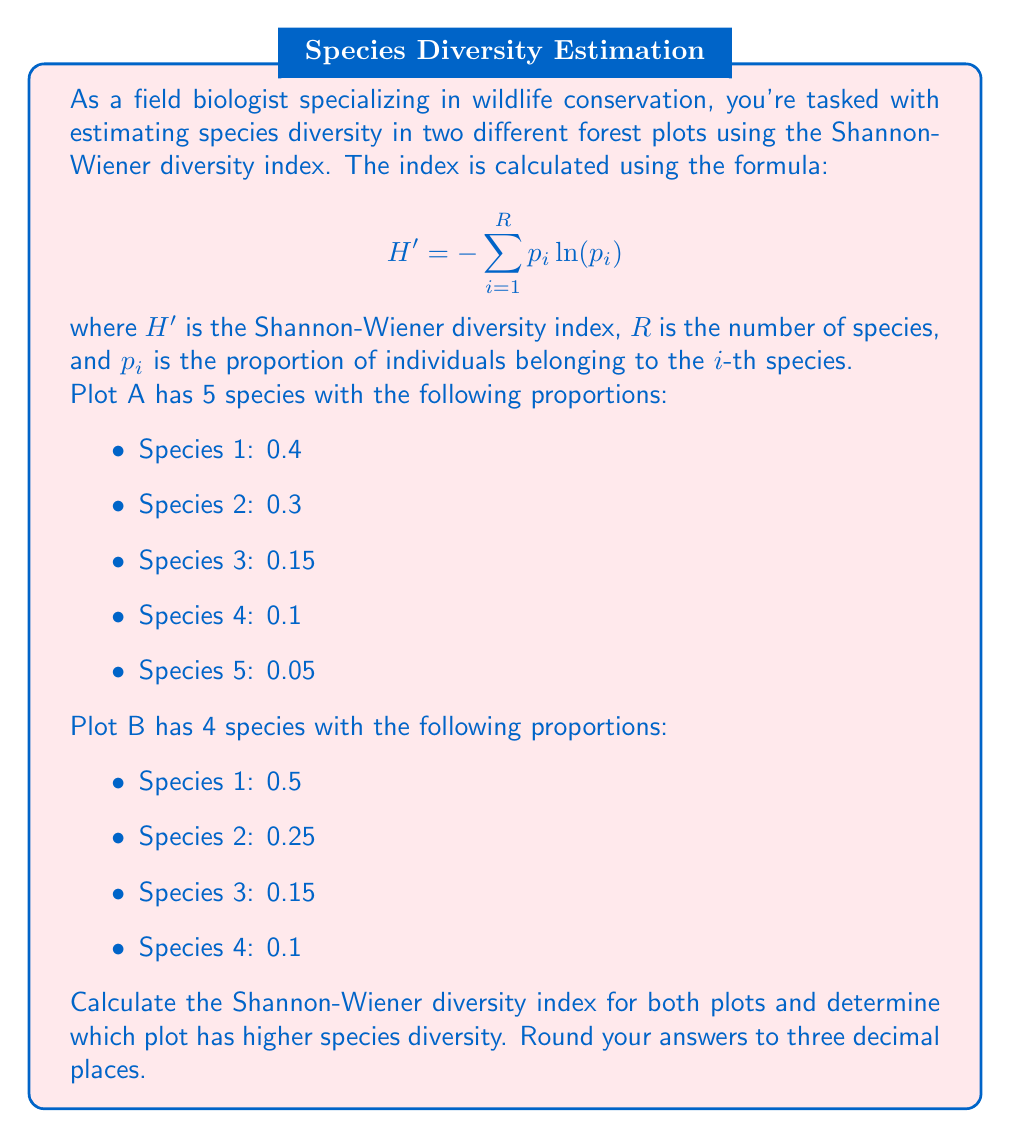Can you solve this math problem? Let's calculate the Shannon-Wiener diversity index for each plot:

For Plot A:
$$\begin{align}
H'_A &= -[(0.4 \ln(0.4)) + (0.3 \ln(0.3)) + (0.15 \ln(0.15)) + (0.1 \ln(0.1)) + (0.05 \ln(0.05))] \\
&= -[-0.3665 - 0.3611 - 0.2855 - 0.2303 - 0.1498] \\
&= 1.3932
\end{align}$$

For Plot B:
$$\begin{align}
H'_B &= -[(0.5 \ln(0.5)) + (0.25 \ln(0.25)) + (0.15 \ln(0.15)) + (0.1 \ln(0.1))] \\
&= -[-0.3466 - 0.3466 - 0.2855 - 0.2303] \\
&= 1.2090
\end{align}$$

Rounding both results to three decimal places:
$H'_A = 1.393$
$H'_B = 1.209$

The Shannon-Wiener diversity index takes into account both species richness (number of species) and evenness (how equally abundant the species are). A higher value indicates greater diversity.

In this case, Plot A has a higher Shannon-Wiener diversity index (1.393) compared to Plot B (1.209). This suggests that Plot A has higher species diversity, which can be attributed to both its greater number of species (5 vs. 4) and its more even distribution of individuals among species.
Answer: Plot A has higher species diversity with a Shannon-Wiener diversity index of 1.393, compared to Plot B with an index of 1.209. 